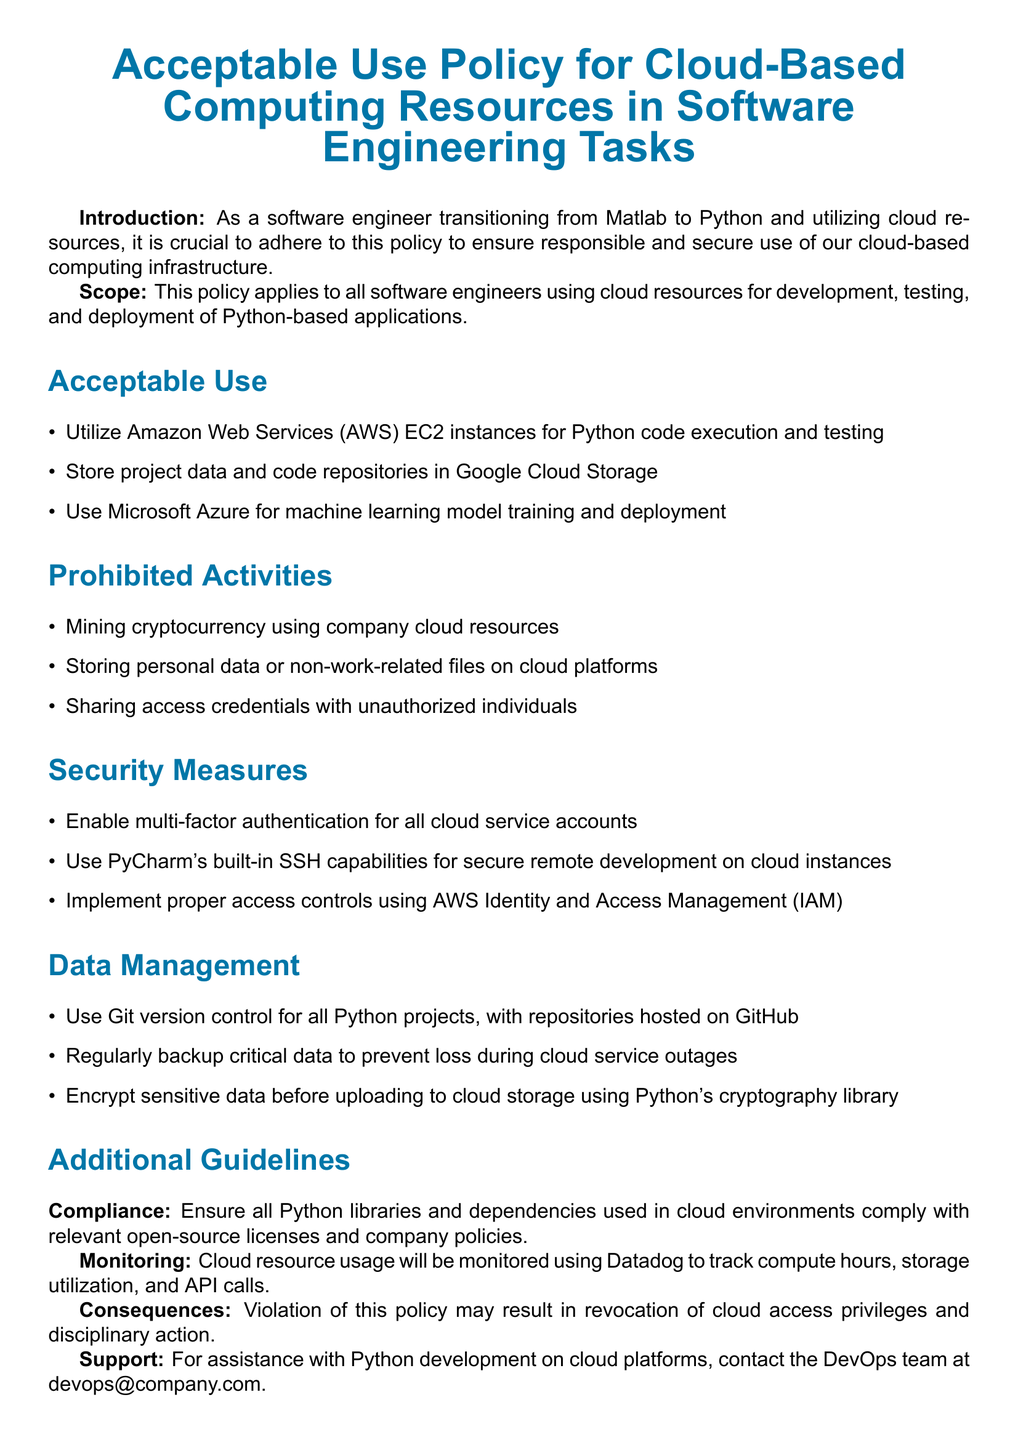What is the purpose of the policy? The purpose is to ensure responsible and secure use of cloud-based computing infrastructure for software engineers.
Answer: to ensure responsible and secure use Which cloud service is specified for machine learning? The policy specifies Microsoft Azure for machine learning-related tasks.
Answer: Microsoft Azure What should be enabled for all cloud service accounts? The policy states that multi-factor authentication should be enabled for security.
Answer: multi-factor authentication Which library is mentioned for data encryption? The document refers to Python's cryptography library for encrypting sensitive data.
Answer: cryptography library What consequence is mentioned for policy violation? The document states that violations may result in revocation of cloud access privileges.
Answer: revocation of cloud access privileges What storage solution should project data use? The policy specifies that project data and code repositories should be stored in Google Cloud Storage.
Answer: Google Cloud Storage How will cloud resource usage be monitored? The document indicates that Datadog will be used for monitoring cloud resource usage.
Answer: Datadog Which version control system is recommended for Python projects? The policy recommends using Git version control for all Python projects.
Answer: Git 